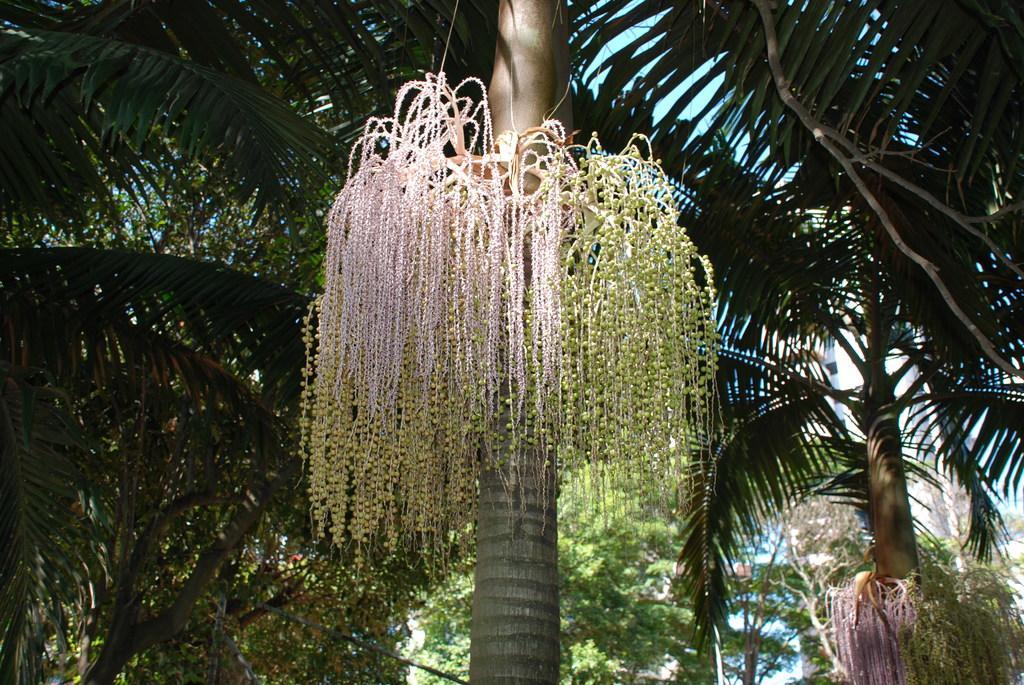How would you summarize this image in a sentence or two? In the picture I can see trees. In the background I can see the sky. 